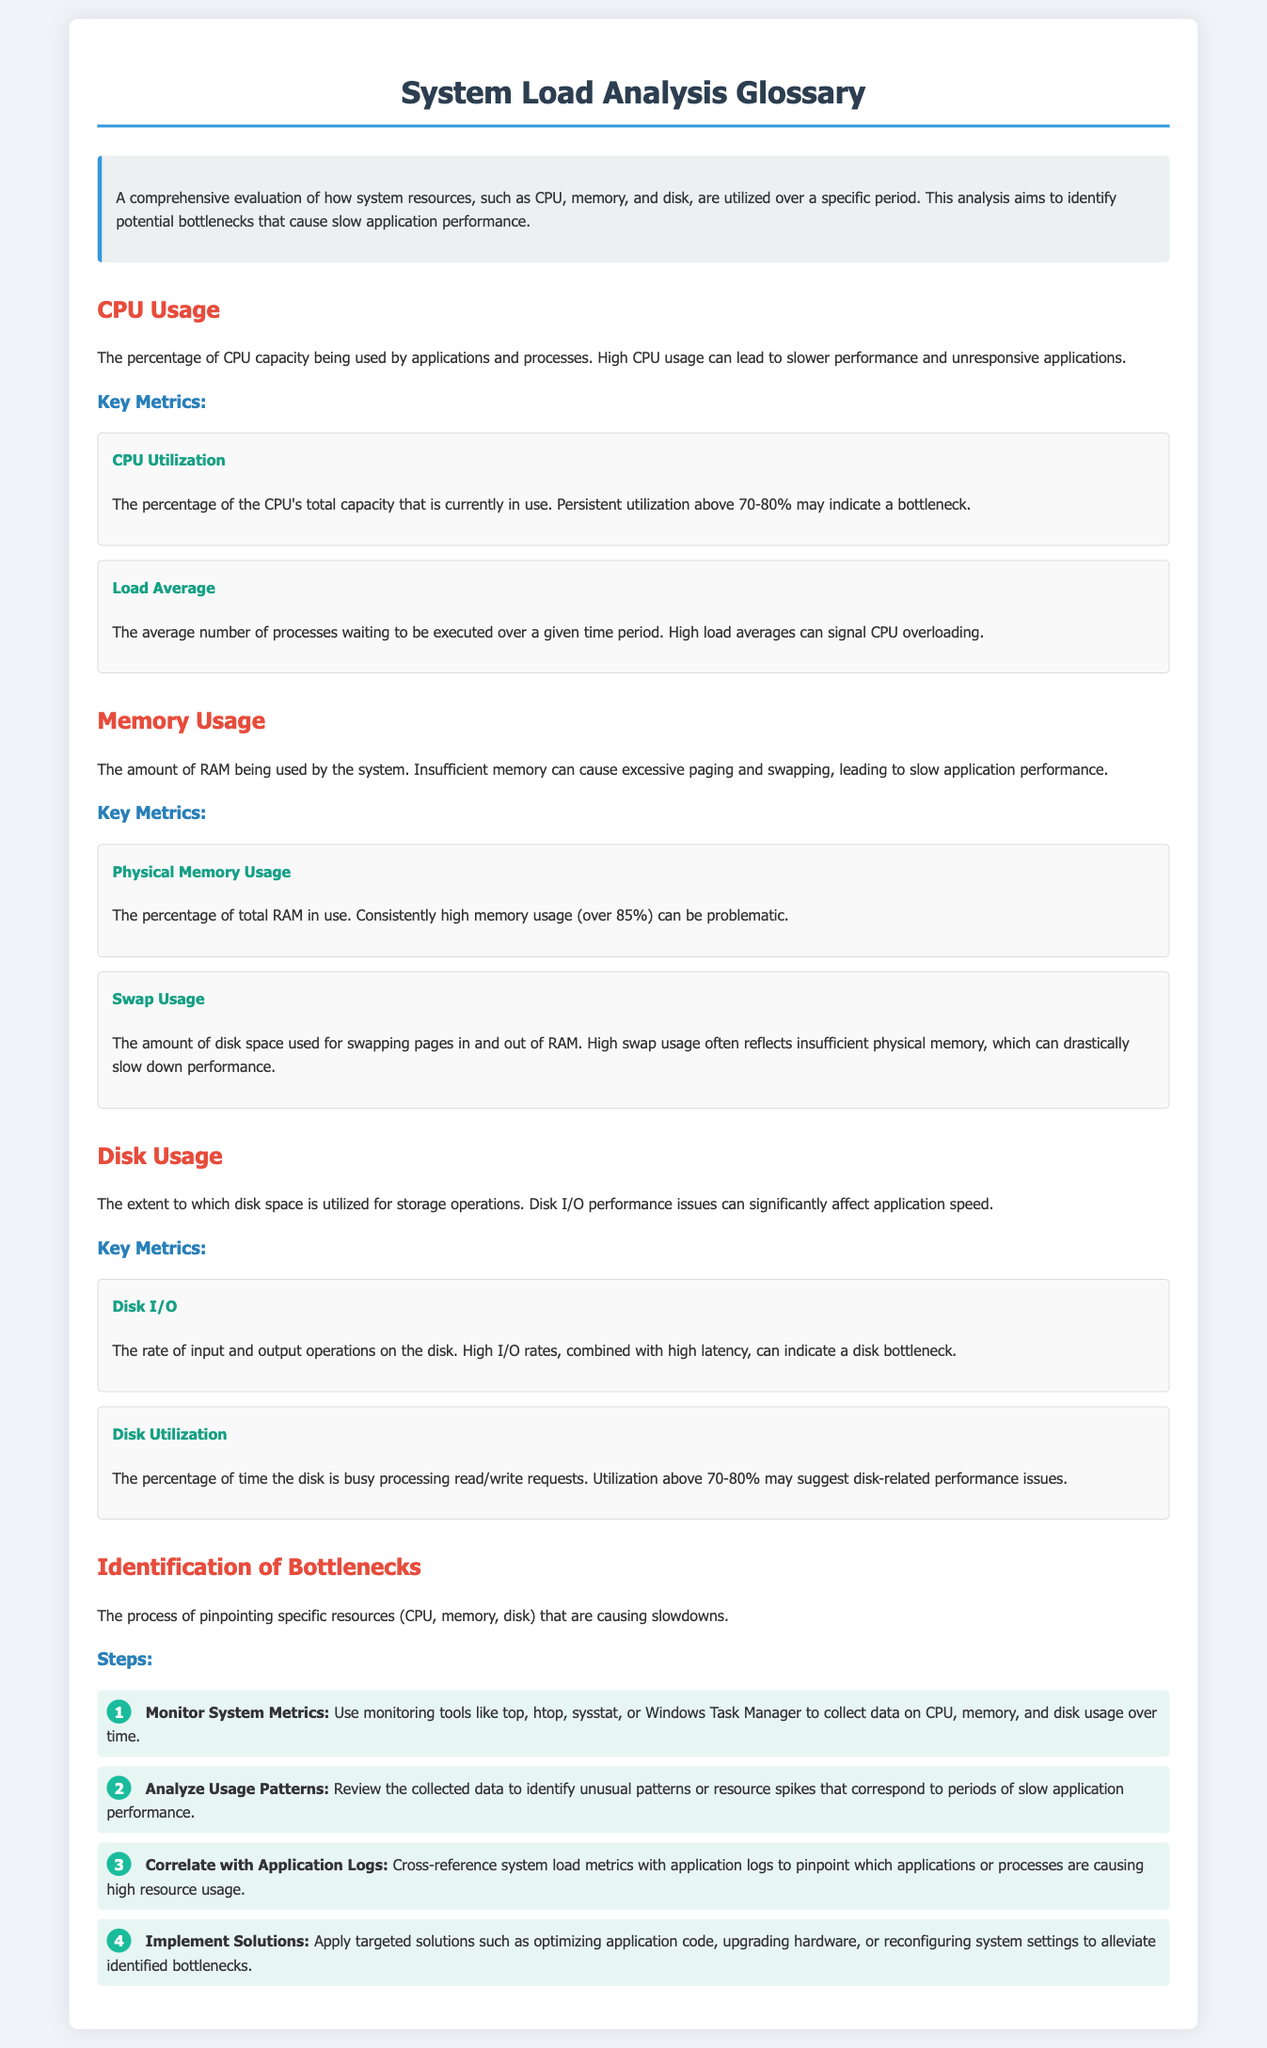What is the primary purpose of system load analysis? The primary purpose of system load analysis is to identify potential bottlenecks that cause slow application performance.
Answer: Identify potential bottlenecks What percentage of CPU utilization may indicate a bottleneck? Persistent CPU utilization above 70-80% may indicate a bottleneck.
Answer: Above 70-80% What is the definition of physical memory usage? Physical memory usage is the percentage of total RAM in use.
Answer: Percentage of total RAM in use What does high swap usage reflect? High swap usage often reflects insufficient physical memory.
Answer: Insufficient physical memory What key metric indicates high disk-related performance issues? Disk utilization above 70-80% may suggest disk-related performance issues.
Answer: Above 70-80% What tool can be used to monitor system metrics? Tools like top, htop, sysstat, or Windows Task Manager can be used to monitor system metrics.
Answer: top, htop, sysstat, Windows Task Manager What is the first step in identifying bottlenecks? The first step is to monitor system metrics.
Answer: Monitor system metrics What is the result of inconsistent memory usage above 85%? Consistently high memory usage over 85% can be problematic.
Answer: Problematic How can you correlate resource usage with application performance? By cross-referencing system load metrics with application logs.
Answer: Cross-reference with application logs 